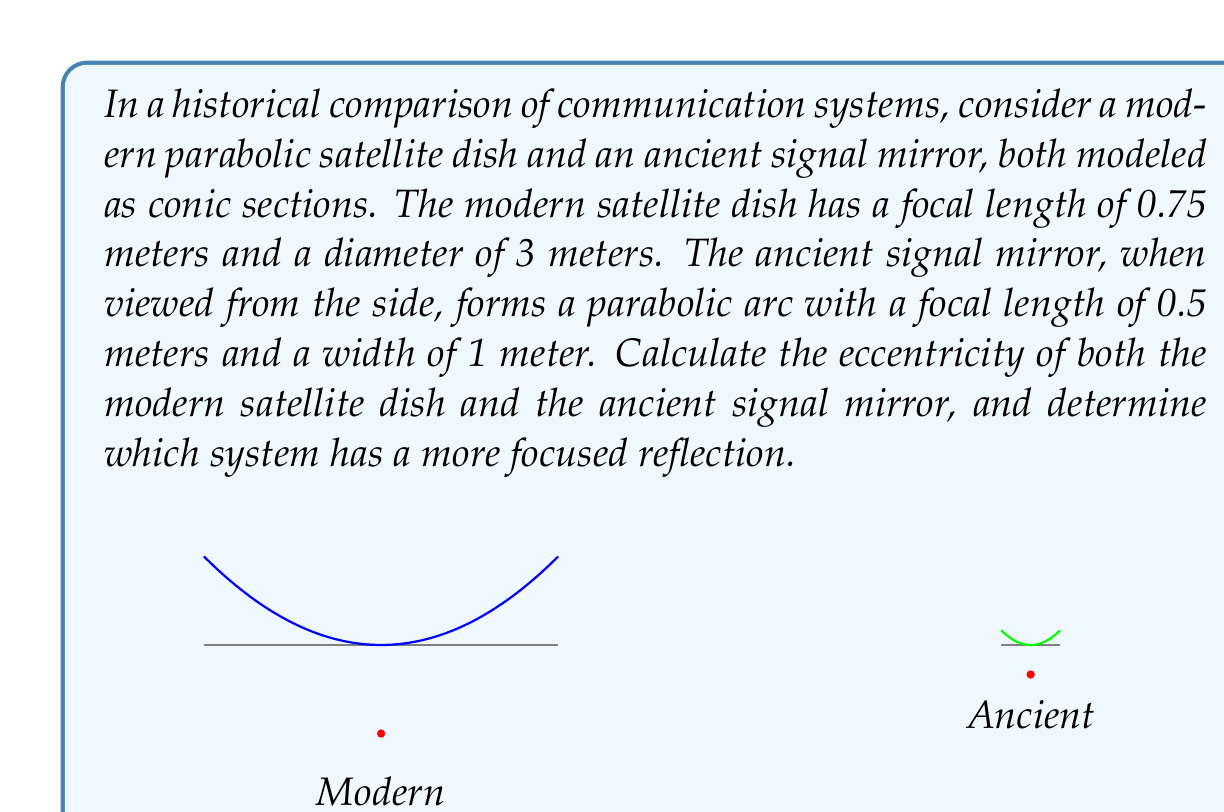Provide a solution to this math problem. Let's approach this step-by-step:

1) For a parabola, the eccentricity is always 1. However, we'll calculate it using the general formula to demonstrate the process.

2) The eccentricity (e) of a conic section is given by the formula:

   $$e = \sqrt{1 + \frac{b^2}{a^2}}$$

   where $a$ is the distance from the vertex to the focus (focal length), and $b$ is the semi-minor axis.

3) For the modern satellite dish:
   - Focal length (a) = 0.75 m
   - Radius (r) = 1.5 m (half of the diameter)

   We can find $b$ using the equation of a parabola: $x^2 = 4ay$
   At the edge of the dish: $1.5^2 = 4(0.75)y$
   Solving for y: $y = 0.75$ m

   Now we can calculate $b$ using the Pythagorean theorem:
   $$b^2 = r^2 - a^2 = 1.5^2 - 0.75^2 = 1.6875$$

   Substituting into the eccentricity formula:
   $$e_{modern} = \sqrt{1 + \frac{1.6875}{0.75^2}} = \sqrt{4} = 2$$

4) For the ancient signal mirror:
   - Focal length (a) = 0.5 m
   - Radius (r) = 0.5 m (half of the width)

   Using the same process as above:
   $0.5^2 = 4(0.5)y$
   $y = 0.125$ m

   $$b^2 = 0.5^2 - 0.5^2 = 0$$

   $$e_{ancient} = \sqrt{1 + \frac{0}{0.5^2}} = 1$$

5) Both systems have an eccentricity of 1, which is characteristic of all parabolas. This means they both have equally focused reflections in theory. However, the modern satellite dish has a larger size and focal length, which allows it to collect and focus more signal in practice.
Answer: $e_{modern} = e_{ancient} = 1$. Both have equally focused reflections theoretically, but the modern dish is more effective due to its larger size. 